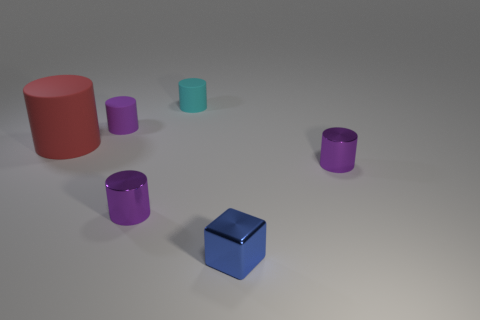Subtract all large rubber cylinders. How many cylinders are left? 4 Subtract all red cylinders. How many cylinders are left? 4 Subtract 2 cylinders. How many cylinders are left? 3 Subtract all brown cylinders. Subtract all green spheres. How many cylinders are left? 5 Subtract all brown spheres. How many cyan cylinders are left? 1 Subtract all rubber cylinders. Subtract all big red objects. How many objects are left? 2 Add 6 matte objects. How many matte objects are left? 9 Add 3 tiny blue metal objects. How many tiny blue metal objects exist? 4 Add 3 shiny cylinders. How many objects exist? 9 Subtract 1 blue cubes. How many objects are left? 5 